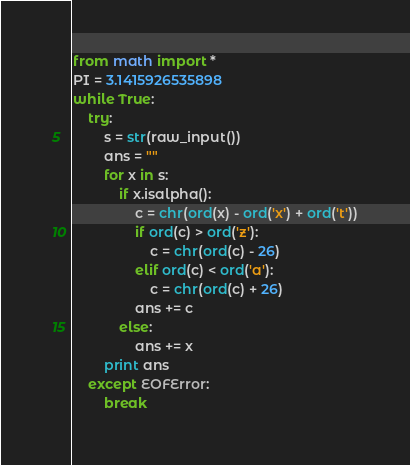Convert code to text. <code><loc_0><loc_0><loc_500><loc_500><_Python_>from math import *
PI = 3.1415926535898
while True:
	try:
		s = str(raw_input())
		ans = ""
		for x in s:
		 	if x.isalpha():
		 		c = chr(ord(x) - ord('x') + ord('t'))
		 		if ord(c) > ord('z'):
		 			c = chr(ord(c) - 26)
		 		elif ord(c) < ord('a'):
		 			c = chr(ord(c) + 26)
		 		ans += c
		 	else:
		 		ans += x
		print ans
	except EOFError:
		break</code> 